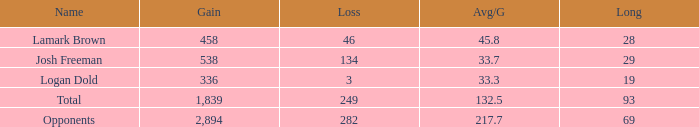Which Long is the highest one that has a Loss larger than 3, and a Gain larger than 2,894? None. 